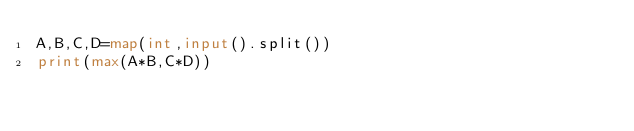Convert code to text. <code><loc_0><loc_0><loc_500><loc_500><_Python_>A,B,C,D=map(int,input().split())
print(max(A*B,C*D))</code> 